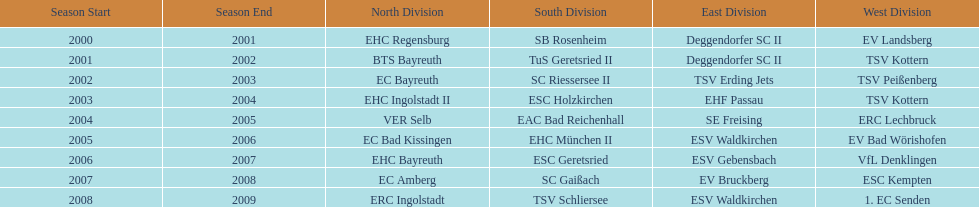The last team to win the west? 1. EC Senden. 